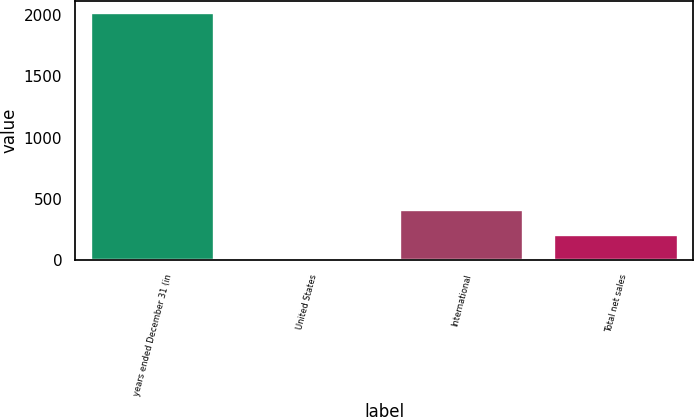Convert chart. <chart><loc_0><loc_0><loc_500><loc_500><bar_chart><fcel>years ended December 31 (in<fcel>United States<fcel>International<fcel>Total net sales<nl><fcel>2013<fcel>7<fcel>408.2<fcel>207.6<nl></chart> 